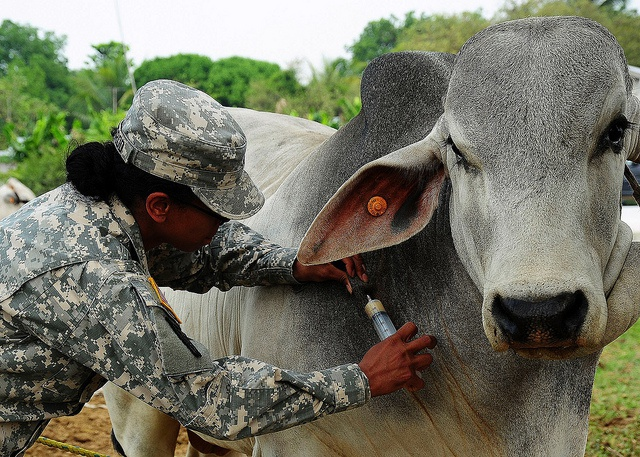Describe the objects in this image and their specific colors. I can see cow in white, gray, black, and darkgray tones and people in white, black, gray, darkgray, and maroon tones in this image. 